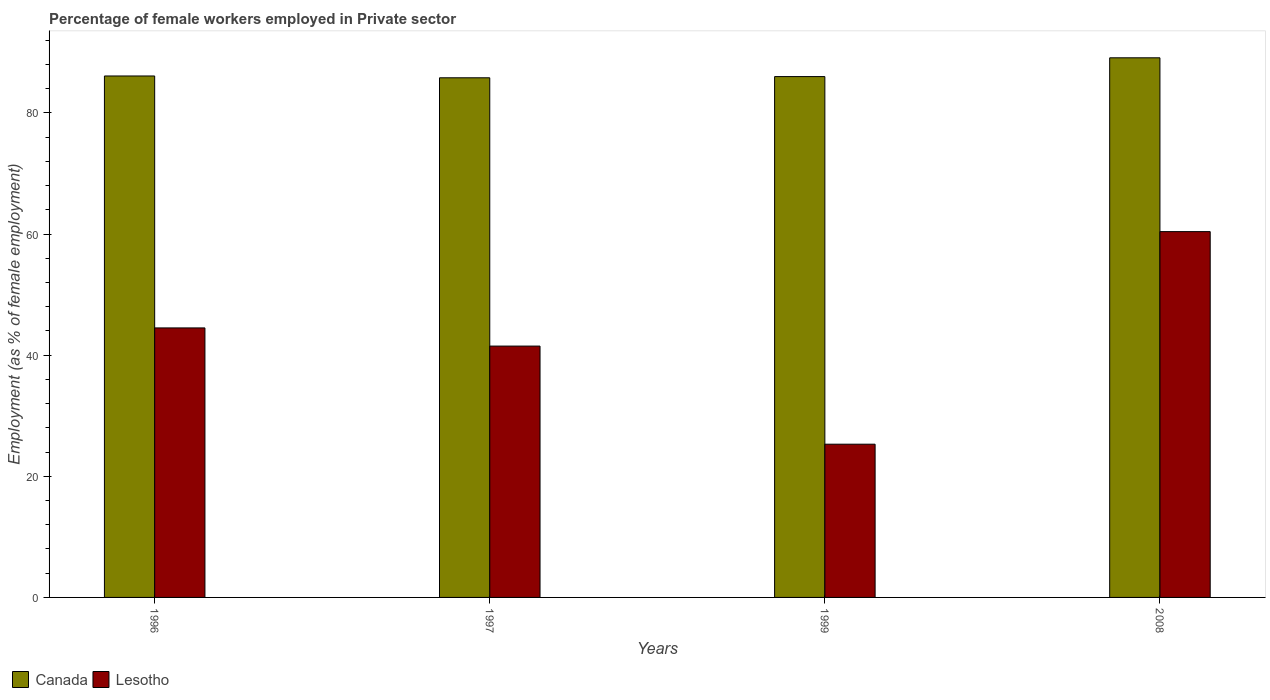How many bars are there on the 1st tick from the right?
Give a very brief answer. 2. What is the label of the 4th group of bars from the left?
Keep it short and to the point. 2008. In how many cases, is the number of bars for a given year not equal to the number of legend labels?
Offer a terse response. 0. What is the percentage of females employed in Private sector in Lesotho in 1996?
Give a very brief answer. 44.5. Across all years, what is the maximum percentage of females employed in Private sector in Lesotho?
Offer a terse response. 60.4. Across all years, what is the minimum percentage of females employed in Private sector in Canada?
Make the answer very short. 85.8. What is the total percentage of females employed in Private sector in Canada in the graph?
Provide a short and direct response. 347. What is the difference between the percentage of females employed in Private sector in Canada in 1997 and that in 2008?
Your answer should be compact. -3.3. What is the difference between the percentage of females employed in Private sector in Canada in 1997 and the percentage of females employed in Private sector in Lesotho in 1999?
Give a very brief answer. 60.5. What is the average percentage of females employed in Private sector in Canada per year?
Provide a short and direct response. 86.75. In the year 1997, what is the difference between the percentage of females employed in Private sector in Canada and percentage of females employed in Private sector in Lesotho?
Your response must be concise. 44.3. In how many years, is the percentage of females employed in Private sector in Lesotho greater than 16 %?
Provide a short and direct response. 4. What is the ratio of the percentage of females employed in Private sector in Lesotho in 1996 to that in 1999?
Ensure brevity in your answer.  1.76. What is the difference between the highest and the second highest percentage of females employed in Private sector in Lesotho?
Your response must be concise. 15.9. What is the difference between the highest and the lowest percentage of females employed in Private sector in Canada?
Make the answer very short. 3.3. What does the 2nd bar from the left in 1996 represents?
Your response must be concise. Lesotho. What does the 2nd bar from the right in 1997 represents?
Your answer should be very brief. Canada. Are all the bars in the graph horizontal?
Give a very brief answer. No. What is the difference between two consecutive major ticks on the Y-axis?
Provide a succinct answer. 20. How are the legend labels stacked?
Provide a short and direct response. Horizontal. What is the title of the graph?
Offer a terse response. Percentage of female workers employed in Private sector. What is the label or title of the X-axis?
Provide a succinct answer. Years. What is the label or title of the Y-axis?
Offer a terse response. Employment (as % of female employment). What is the Employment (as % of female employment) in Canada in 1996?
Your answer should be compact. 86.1. What is the Employment (as % of female employment) of Lesotho in 1996?
Offer a terse response. 44.5. What is the Employment (as % of female employment) in Canada in 1997?
Make the answer very short. 85.8. What is the Employment (as % of female employment) in Lesotho in 1997?
Your response must be concise. 41.5. What is the Employment (as % of female employment) in Canada in 1999?
Offer a terse response. 86. What is the Employment (as % of female employment) of Lesotho in 1999?
Make the answer very short. 25.3. What is the Employment (as % of female employment) in Canada in 2008?
Give a very brief answer. 89.1. What is the Employment (as % of female employment) in Lesotho in 2008?
Your answer should be compact. 60.4. Across all years, what is the maximum Employment (as % of female employment) in Canada?
Provide a short and direct response. 89.1. Across all years, what is the maximum Employment (as % of female employment) in Lesotho?
Ensure brevity in your answer.  60.4. Across all years, what is the minimum Employment (as % of female employment) of Canada?
Give a very brief answer. 85.8. Across all years, what is the minimum Employment (as % of female employment) in Lesotho?
Provide a short and direct response. 25.3. What is the total Employment (as % of female employment) of Canada in the graph?
Offer a terse response. 347. What is the total Employment (as % of female employment) in Lesotho in the graph?
Ensure brevity in your answer.  171.7. What is the difference between the Employment (as % of female employment) in Lesotho in 1996 and that in 2008?
Your answer should be compact. -15.9. What is the difference between the Employment (as % of female employment) of Canada in 1997 and that in 1999?
Make the answer very short. -0.2. What is the difference between the Employment (as % of female employment) in Lesotho in 1997 and that in 2008?
Give a very brief answer. -18.9. What is the difference between the Employment (as % of female employment) in Lesotho in 1999 and that in 2008?
Your answer should be very brief. -35.1. What is the difference between the Employment (as % of female employment) in Canada in 1996 and the Employment (as % of female employment) in Lesotho in 1997?
Make the answer very short. 44.6. What is the difference between the Employment (as % of female employment) of Canada in 1996 and the Employment (as % of female employment) of Lesotho in 1999?
Keep it short and to the point. 60.8. What is the difference between the Employment (as % of female employment) of Canada in 1996 and the Employment (as % of female employment) of Lesotho in 2008?
Make the answer very short. 25.7. What is the difference between the Employment (as % of female employment) in Canada in 1997 and the Employment (as % of female employment) in Lesotho in 1999?
Your answer should be very brief. 60.5. What is the difference between the Employment (as % of female employment) of Canada in 1997 and the Employment (as % of female employment) of Lesotho in 2008?
Provide a short and direct response. 25.4. What is the difference between the Employment (as % of female employment) of Canada in 1999 and the Employment (as % of female employment) of Lesotho in 2008?
Your answer should be very brief. 25.6. What is the average Employment (as % of female employment) of Canada per year?
Keep it short and to the point. 86.75. What is the average Employment (as % of female employment) of Lesotho per year?
Offer a terse response. 42.92. In the year 1996, what is the difference between the Employment (as % of female employment) in Canada and Employment (as % of female employment) in Lesotho?
Offer a very short reply. 41.6. In the year 1997, what is the difference between the Employment (as % of female employment) of Canada and Employment (as % of female employment) of Lesotho?
Ensure brevity in your answer.  44.3. In the year 1999, what is the difference between the Employment (as % of female employment) in Canada and Employment (as % of female employment) in Lesotho?
Ensure brevity in your answer.  60.7. In the year 2008, what is the difference between the Employment (as % of female employment) of Canada and Employment (as % of female employment) of Lesotho?
Give a very brief answer. 28.7. What is the ratio of the Employment (as % of female employment) of Lesotho in 1996 to that in 1997?
Provide a succinct answer. 1.07. What is the ratio of the Employment (as % of female employment) of Canada in 1996 to that in 1999?
Ensure brevity in your answer.  1. What is the ratio of the Employment (as % of female employment) of Lesotho in 1996 to that in 1999?
Provide a short and direct response. 1.76. What is the ratio of the Employment (as % of female employment) in Canada in 1996 to that in 2008?
Your answer should be compact. 0.97. What is the ratio of the Employment (as % of female employment) in Lesotho in 1996 to that in 2008?
Keep it short and to the point. 0.74. What is the ratio of the Employment (as % of female employment) in Lesotho in 1997 to that in 1999?
Offer a terse response. 1.64. What is the ratio of the Employment (as % of female employment) of Lesotho in 1997 to that in 2008?
Provide a short and direct response. 0.69. What is the ratio of the Employment (as % of female employment) in Canada in 1999 to that in 2008?
Provide a short and direct response. 0.97. What is the ratio of the Employment (as % of female employment) in Lesotho in 1999 to that in 2008?
Offer a terse response. 0.42. What is the difference between the highest and the second highest Employment (as % of female employment) in Canada?
Ensure brevity in your answer.  3. What is the difference between the highest and the lowest Employment (as % of female employment) in Lesotho?
Offer a very short reply. 35.1. 